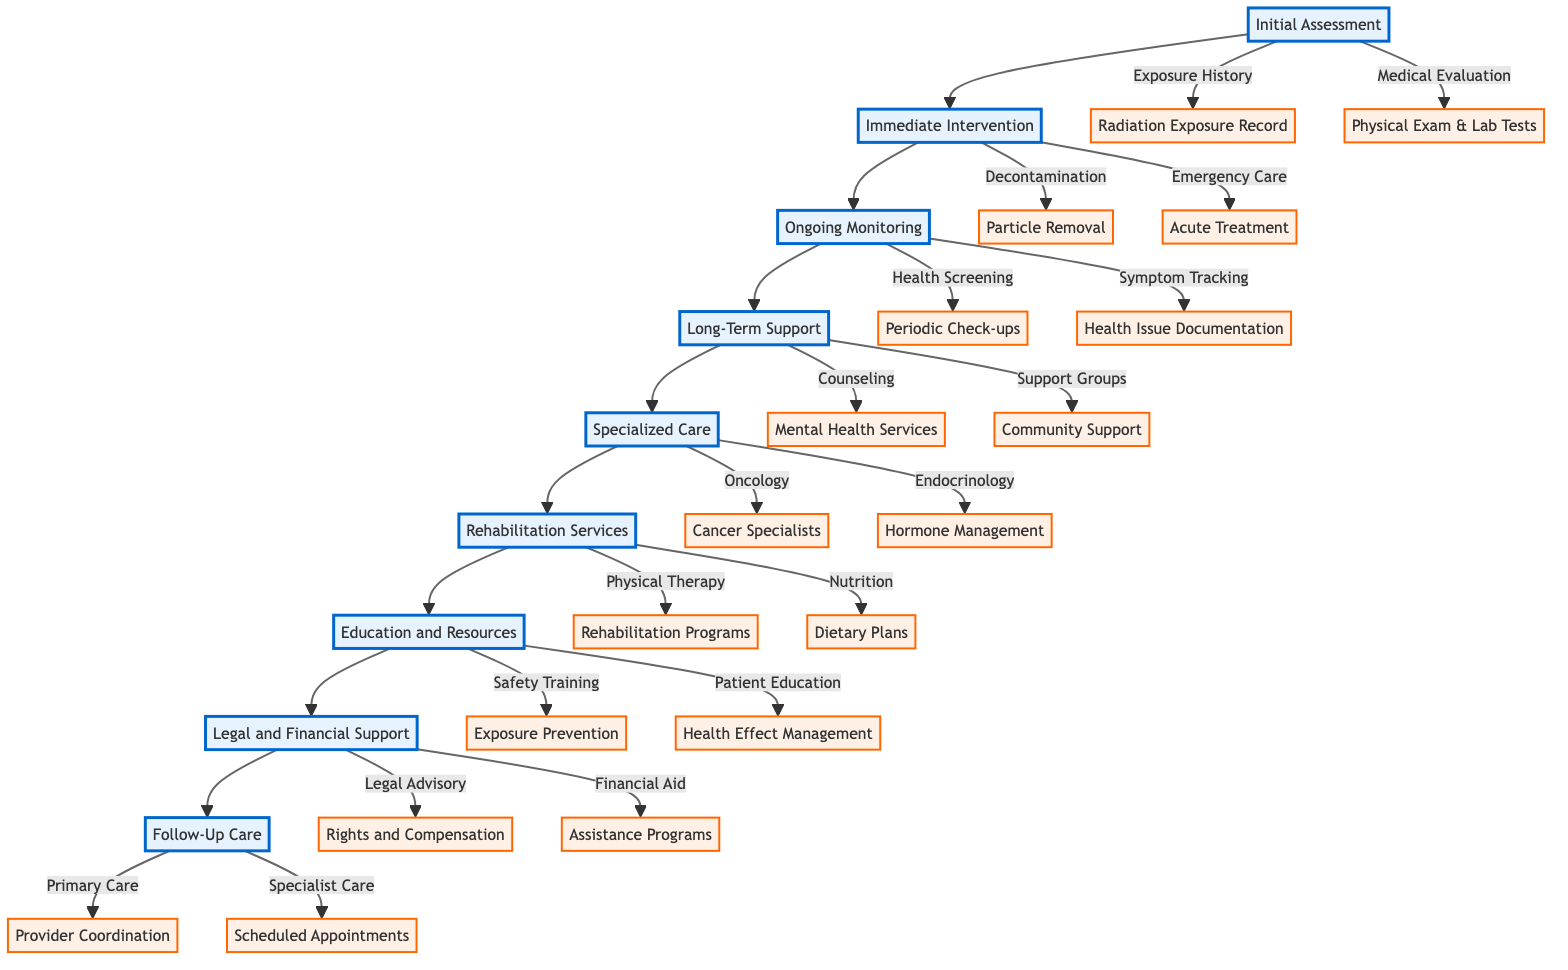What is the first phase in the diagram? The first phase in the diagram is "Initial Assessment", which is directly indicated as the starting node at the top of the clinical pathway.
Answer: Initial Assessment How many phases are indicated in the diagram? Counting the distinct phases from "Initial Assessment" to "Follow-Up Care" gives a total of eight phases in the clinical pathway.
Answer: 8 What type of support is provided during the "Long-Term Support" phase? The "Long-Term Support" phase offers "Psychological Counseling" and "Support Groups" as the types of support available to individuals exposed to nuclear radiation.
Answer: Psychological Counseling, Support Groups Which phase follows "Ongoing Monitoring"? The phase that directly follows "Ongoing Monitoring" in the flow of the diagram is "Long-Term Support", as indicated by the directed arrows connecting the phases.
Answer: Long-Term Support What is the focus of the "Education and Resources" phase? The focus of the "Education and Resources" phase is on providing "Radiation Safety Training" and "Patient Education", which are intended to inform individuals about managing exposure and health effects.
Answer: Radiation Safety Training, Patient Education What immediate action is associated with the "Immediate Intervention" phase? The immediate actions associated with the "Immediate Intervention" phase are "Decontamination" and "Emergency Care", focusing on the acute response to radiation exposure.
Answer: Decontamination, Emergency Care What type of professionals are involved in the "Specialized Care" phase? The "Specialized Care" phase includes professionals in "Oncology" and "Endocrinology", indicating specialists who handle radiation-induced cancer and hormone-related disorders respectively.
Answer: Oncology, Endocrinology How does "Follow-Up Care" ensure ongoing health management? "Follow-Up Care" ensures ongoing health management through "Primary Care Coordination" and "Specialist Appointments", emphasizing collaboration with care providers for continued health monitoring.
Answer: Primary Care Coordination, Specialist Appointments 